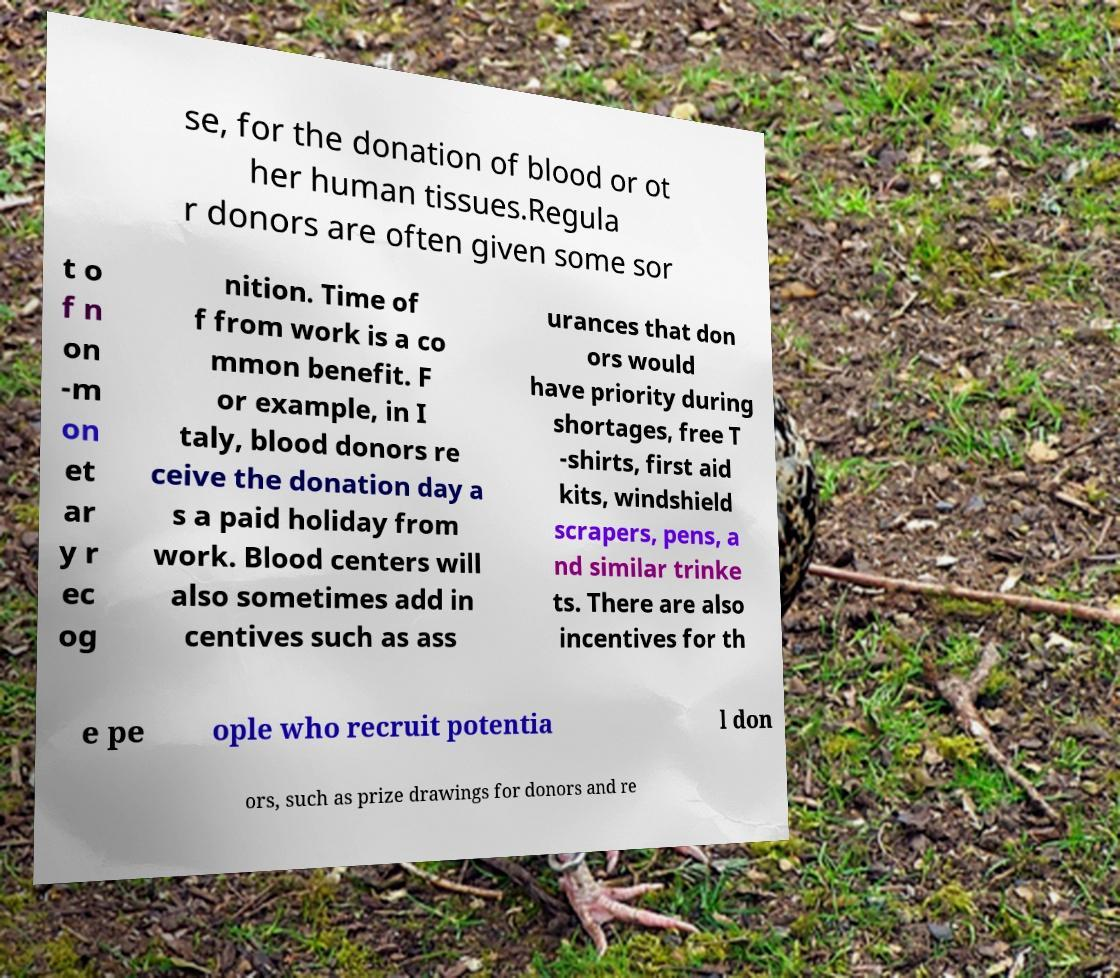What messages or text are displayed in this image? I need them in a readable, typed format. se, for the donation of blood or ot her human tissues.Regula r donors are often given some sor t o f n on -m on et ar y r ec og nition. Time of f from work is a co mmon benefit. F or example, in I taly, blood donors re ceive the donation day a s a paid holiday from work. Blood centers will also sometimes add in centives such as ass urances that don ors would have priority during shortages, free T -shirts, first aid kits, windshield scrapers, pens, a nd similar trinke ts. There are also incentives for th e pe ople who recruit potentia l don ors, such as prize drawings for donors and re 